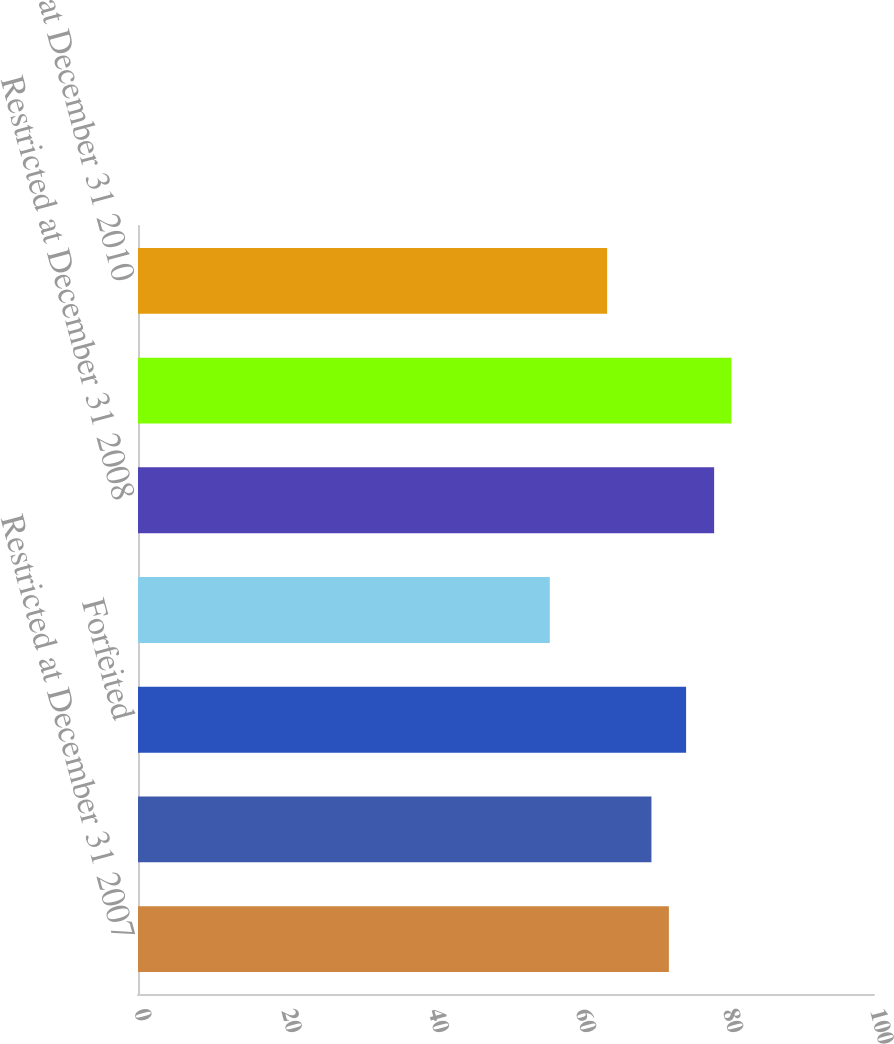Convert chart. <chart><loc_0><loc_0><loc_500><loc_500><bar_chart><fcel>Restricted at December 31 2007<fcel>Granted<fcel>Forfeited<fcel>Released<fcel>Restricted at December 31 2008<fcel>Restricted at December 31 2009<fcel>Restricted at December 31 2010<nl><fcel>72.13<fcel>69.76<fcel>74.47<fcel>55.95<fcel>78.28<fcel>80.62<fcel>63.74<nl></chart> 